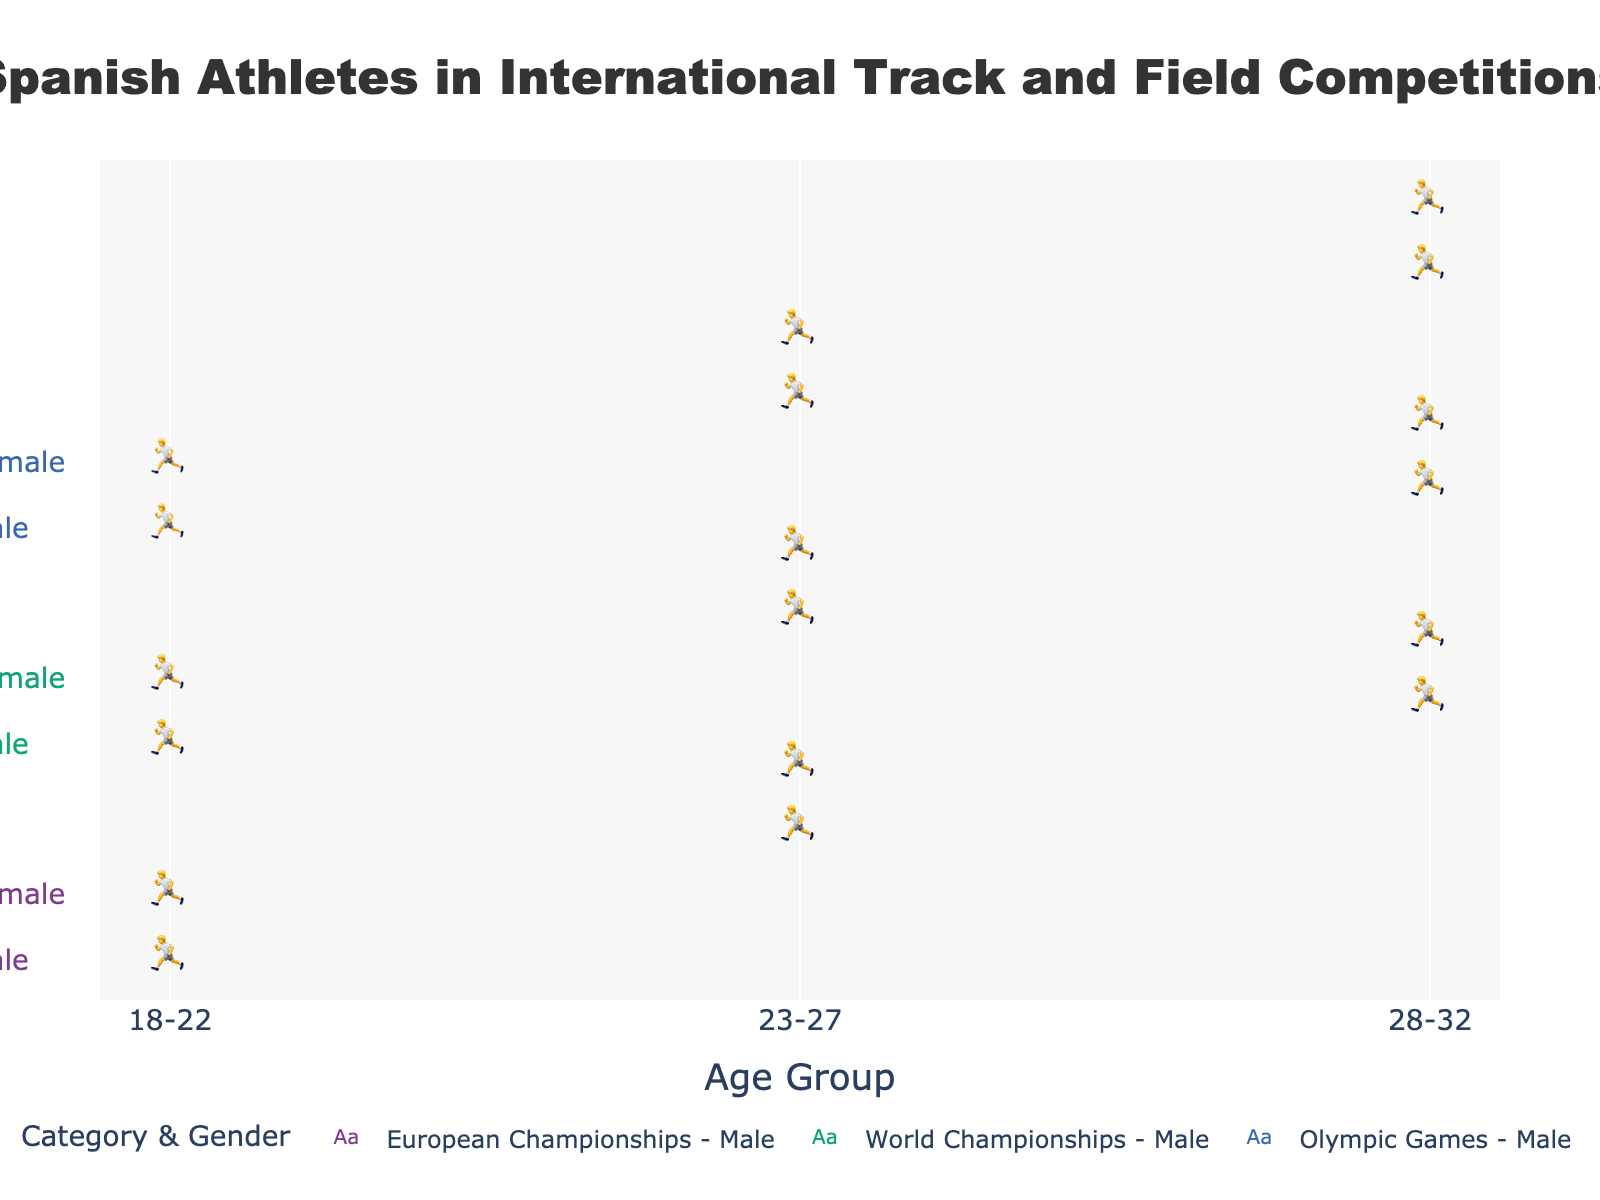Which age group has the highest number of male athletes in the European Championships? Look at the "European Championships" category and find the age group with the most male athlete icons. The "23-27" age group has 8 male athletes.
Answer: 23-27 How many total female athletes participated in the World Championships across all age groups? Sum the number of female athletes in the "World Championships" for all age groups (2 + 5 + 3).
Answer: 10 Are there more male or female athletes aged 28-32 in the Olympic Games? Compare the athletes in the "28-32" age group for male (3) and female (2) in the "Olympic Games" category.
Answer: Male Which gender had more athletes in the "18-22" age group in the European Championships? Compare the number of male (5) and female (4) athletes in the "18-22" age group for the "European Championships."
Answer: Male What's the total number of male athletes in the age group "23-27" across all competitions? Sum the number of male athletes in the "23-27" age group for all categories: European Championships (8), World Championships (6), and Olympic Games (4).
Answer: 18 Which age group has the fewest athletes in the World Championships? Compare the total athletes in each age group for the "World Championships": 18-22 (3+2=5), 23-27 (6+5=11), 28-32 (4+3=7). The age group "18-22" has the fewest.
Answer: 18-22 Between the European Championships and Olympic Games, which has more athletes in the "18-22" age group? Sum the athletes in the "18-22" age group for the "European Championships" (5 + 4 = 9) and the "Olympic Games" (1 + 1 = 2). The European Championships has more.
Answer: European Championships How does the representation of male athletes in the age group 18-22 change from European Championships to Olympic Games? Compare the number of male athletes in the "18-22" age group from "European Championships" (5) to "Olympic Games" (1). The number decreases.
Answer: Decreases Which category has the most athletes aged 28-32? Sum the number of athletes in the "28-32" age group for each category: European Championships (6+5=11), World Championships (4+3=7), and Olympic Games (3+2=5). The European Championships has the most.
Answer: European Championships 